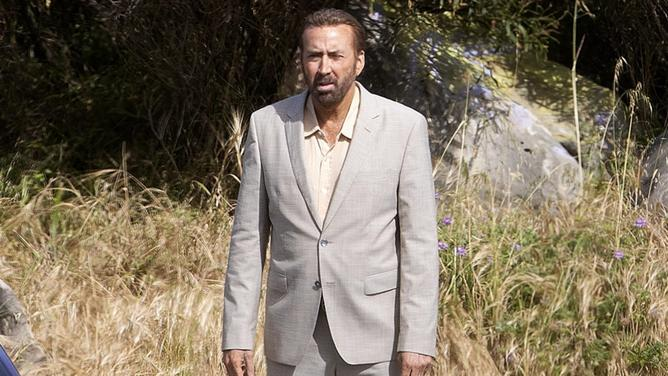Write a detailed description of the given image. The image illustrates a middle-aged man standing in an outdoor setting that features tall, partially dried grass and a few scattered rocks. He is dressed in a beige suit paired with a pale yellow shirt, which contrasts subtly with the wild and natural surroundings. The man's facial expression is stern and contemplative, suggesting that he might be engaged in a serious scenario or deep in thought. His attention is directed off to the side, hinting at either an unseen presence or a moment of reflection. 